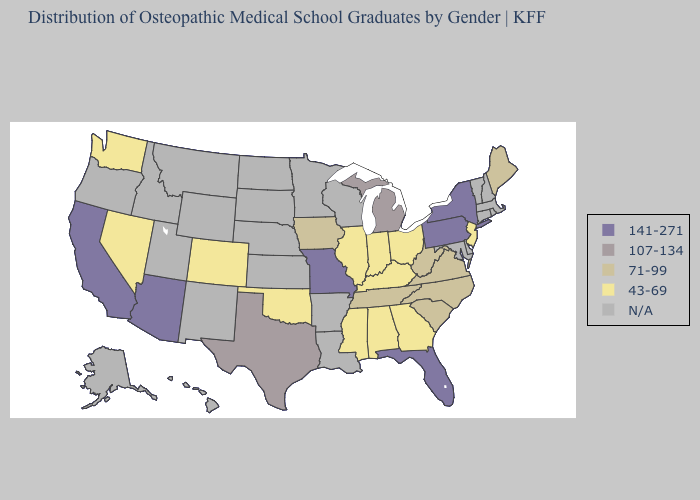Name the states that have a value in the range 141-271?
Write a very short answer. Arizona, California, Florida, Missouri, New York, Pennsylvania. Among the states that border Oklahoma , does Colorado have the lowest value?
Short answer required. Yes. Does the first symbol in the legend represent the smallest category?
Write a very short answer. No. Among the states that border Tennessee , does Virginia have the highest value?
Write a very short answer. No. Which states have the lowest value in the Northeast?
Keep it brief. New Jersey. What is the value of Ohio?
Keep it brief. 43-69. Which states hav the highest value in the Northeast?
Short answer required. New York, Pennsylvania. Among the states that border Missouri , which have the lowest value?
Write a very short answer. Illinois, Kentucky, Oklahoma. What is the lowest value in the South?
Keep it brief. 43-69. Which states have the highest value in the USA?
Give a very brief answer. Arizona, California, Florida, Missouri, New York, Pennsylvania. Among the states that border Delaware , which have the highest value?
Keep it brief. Pennsylvania. Name the states that have a value in the range 107-134?
Write a very short answer. Michigan, Texas. Name the states that have a value in the range 43-69?
Be succinct. Alabama, Colorado, Georgia, Illinois, Indiana, Kentucky, Mississippi, Nevada, New Jersey, Ohio, Oklahoma, Washington. Name the states that have a value in the range 43-69?
Give a very brief answer. Alabama, Colorado, Georgia, Illinois, Indiana, Kentucky, Mississippi, Nevada, New Jersey, Ohio, Oklahoma, Washington. 